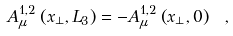<formula> <loc_0><loc_0><loc_500><loc_500>A _ { \mu } ^ { 1 , 2 } \left ( x _ { \perp } , L _ { 3 } \right ) = - A _ { \mu } ^ { 1 , 2 } \left ( x _ { \perp } , 0 \right ) \ ,</formula> 